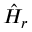Convert formula to latex. <formula><loc_0><loc_0><loc_500><loc_500>\hat { H } _ { r }</formula> 